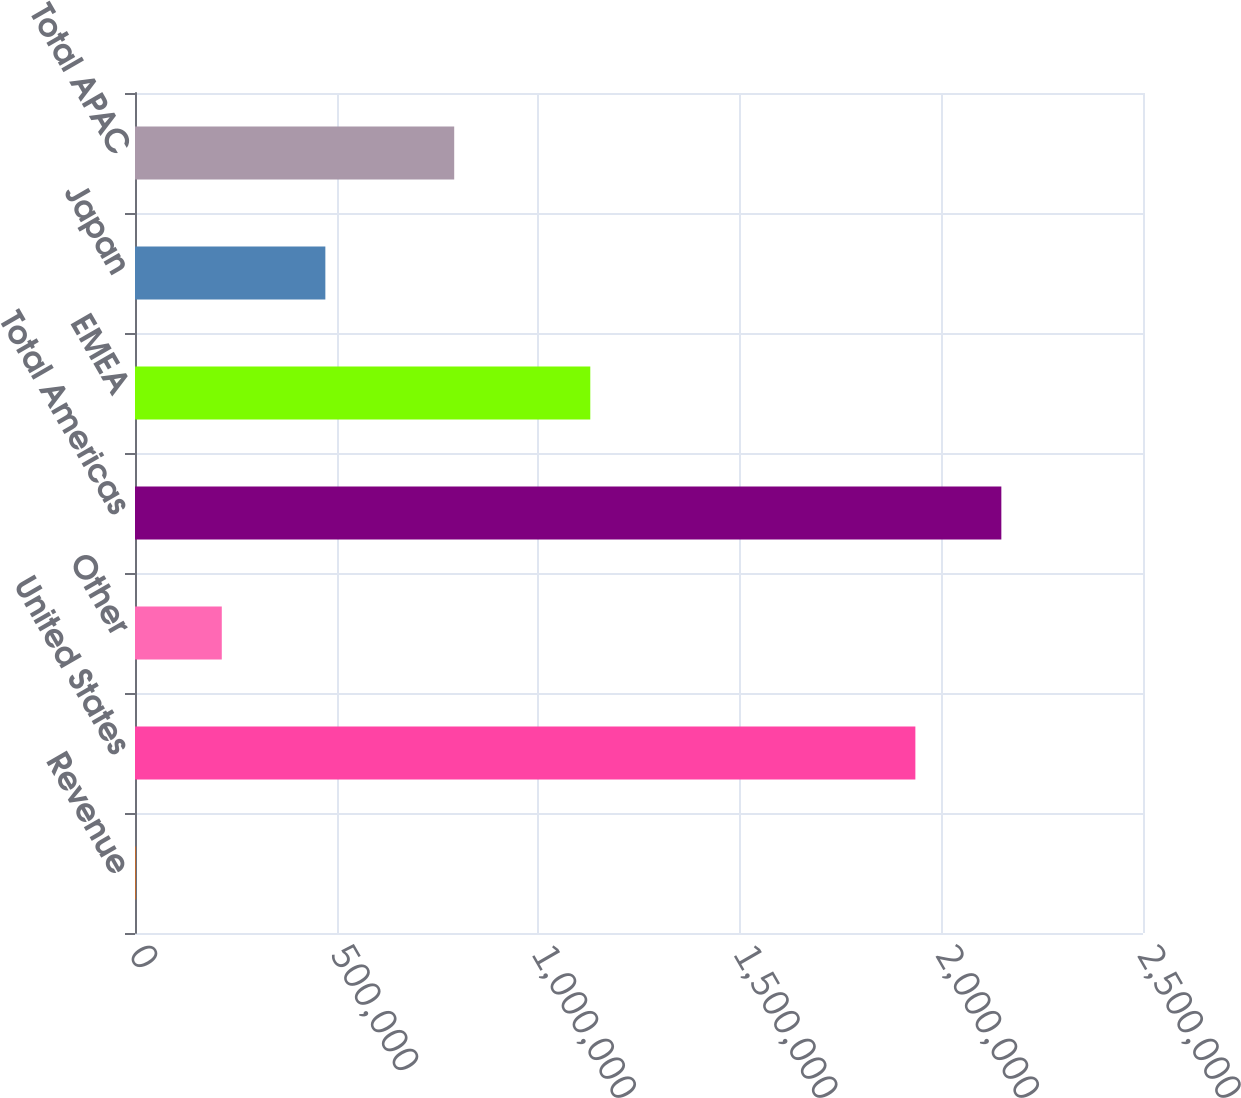Convert chart to OTSL. <chart><loc_0><loc_0><loc_500><loc_500><bar_chart><fcel>Revenue<fcel>United States<fcel>Other<fcel>Total Americas<fcel>EMEA<fcel>Japan<fcel>Total APAC<nl><fcel>2013<fcel>1.93543e+06<fcel>215250<fcel>2.14867e+06<fcel>1.12918e+06<fcel>472110<fcel>791678<nl></chart> 